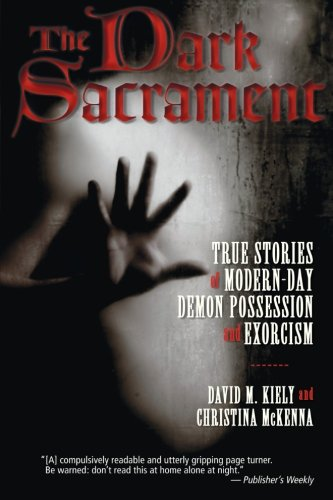Who is the author of this book? The book 'The Dark Sacrament' is co-authored by David Kiely and Christina McKenna. 